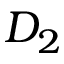<formula> <loc_0><loc_0><loc_500><loc_500>D _ { 2 }</formula> 